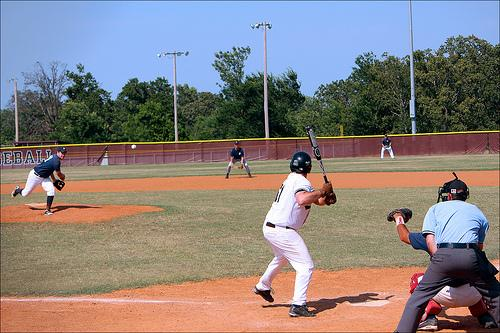List three protective equipment mentioned in the description of this image. Helmet, knee pad/shin pads, and baseball mitt. Create a one-sentence summary of this image in a poetic manner. Underneath the clear blue skies, the game unfolds as players scatter across the grass and dirt, intertwining their fates with every swing and pitch. Discuss one aspect of sportsmanship embodied by the baseball players in the image. The baseball players exhibit cooperation, teamwork, and focus as they all perform their respective roles and responsibilities in the game. What style of clothing is commonly worn by players in the image? Provide two examples. Players wear uniforms, such as a white shirt, white pants, or grey pants, with their respective team colors and logos. What is the main color of the fence of the baseball field? Red What is the color of the umpire's shirt, and what is he doing in the image? The umpire is wearing a blue shirt and watching the game closely, preparing himself for possible outcomes. Estimate the count of the baseball field in its different sections. Grass: Two sections; Dirt: One section. Describe the appearance of the pitcher in the image. The pitcher is wearing a green and white uniform, getting ready to throw the ball. Identify the main action happening in the baseball game. A pitcher is throwing the ball, and the batter is taking stance to swing at it. 